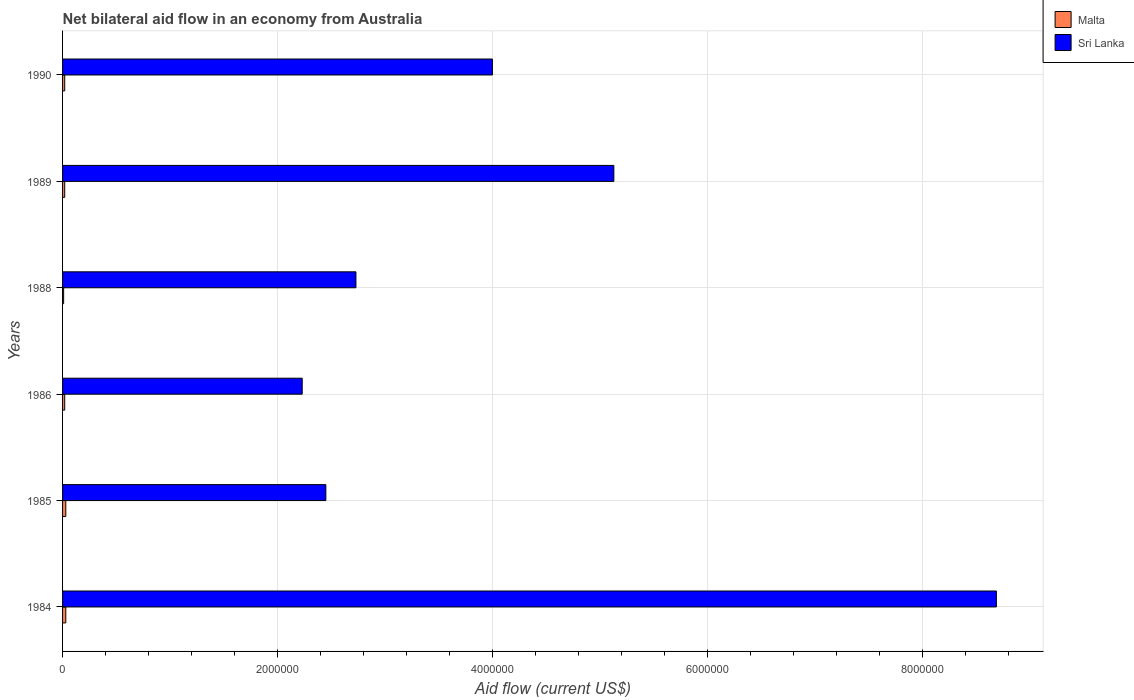How many bars are there on the 2nd tick from the top?
Provide a short and direct response. 2. How many bars are there on the 2nd tick from the bottom?
Provide a succinct answer. 2. What is the label of the 5th group of bars from the top?
Give a very brief answer. 1985. What is the net bilateral aid flow in Malta in 1985?
Your response must be concise. 3.00e+04. Across all years, what is the minimum net bilateral aid flow in Sri Lanka?
Your answer should be compact. 2.23e+06. In which year was the net bilateral aid flow in Sri Lanka minimum?
Your answer should be compact. 1986. What is the total net bilateral aid flow in Sri Lanka in the graph?
Give a very brief answer. 2.52e+07. What is the difference between the net bilateral aid flow in Sri Lanka in 1984 and that in 1989?
Provide a succinct answer. 3.56e+06. What is the difference between the net bilateral aid flow in Malta in 1989 and the net bilateral aid flow in Sri Lanka in 1984?
Keep it short and to the point. -8.67e+06. What is the average net bilateral aid flow in Malta per year?
Your response must be concise. 2.17e+04. In the year 1984, what is the difference between the net bilateral aid flow in Sri Lanka and net bilateral aid flow in Malta?
Your answer should be compact. 8.66e+06. In how many years, is the net bilateral aid flow in Malta greater than 5600000 US$?
Offer a terse response. 0. Is the net bilateral aid flow in Malta in 1984 less than that in 1990?
Ensure brevity in your answer.  No. What is the difference between the highest and the lowest net bilateral aid flow in Malta?
Ensure brevity in your answer.  2.00e+04. What does the 1st bar from the top in 1989 represents?
Ensure brevity in your answer.  Sri Lanka. What does the 2nd bar from the bottom in 1985 represents?
Make the answer very short. Sri Lanka. How many bars are there?
Your answer should be compact. 12. How many years are there in the graph?
Make the answer very short. 6. Are the values on the major ticks of X-axis written in scientific E-notation?
Ensure brevity in your answer.  No. Does the graph contain any zero values?
Give a very brief answer. No. Does the graph contain grids?
Keep it short and to the point. Yes. Where does the legend appear in the graph?
Your answer should be very brief. Top right. How are the legend labels stacked?
Provide a short and direct response. Vertical. What is the title of the graph?
Your answer should be very brief. Net bilateral aid flow in an economy from Australia. What is the label or title of the X-axis?
Your answer should be very brief. Aid flow (current US$). What is the Aid flow (current US$) in Sri Lanka in 1984?
Offer a terse response. 8.69e+06. What is the Aid flow (current US$) of Malta in 1985?
Offer a terse response. 3.00e+04. What is the Aid flow (current US$) in Sri Lanka in 1985?
Your response must be concise. 2.45e+06. What is the Aid flow (current US$) in Sri Lanka in 1986?
Keep it short and to the point. 2.23e+06. What is the Aid flow (current US$) of Malta in 1988?
Provide a short and direct response. 10000. What is the Aid flow (current US$) in Sri Lanka in 1988?
Offer a very short reply. 2.73e+06. What is the Aid flow (current US$) in Sri Lanka in 1989?
Provide a succinct answer. 5.13e+06. What is the Aid flow (current US$) in Malta in 1990?
Provide a succinct answer. 2.00e+04. What is the Aid flow (current US$) in Sri Lanka in 1990?
Your answer should be compact. 4.00e+06. Across all years, what is the maximum Aid flow (current US$) in Sri Lanka?
Offer a very short reply. 8.69e+06. Across all years, what is the minimum Aid flow (current US$) of Malta?
Provide a succinct answer. 10000. Across all years, what is the minimum Aid flow (current US$) in Sri Lanka?
Provide a short and direct response. 2.23e+06. What is the total Aid flow (current US$) of Malta in the graph?
Provide a short and direct response. 1.30e+05. What is the total Aid flow (current US$) in Sri Lanka in the graph?
Your answer should be compact. 2.52e+07. What is the difference between the Aid flow (current US$) of Sri Lanka in 1984 and that in 1985?
Make the answer very short. 6.24e+06. What is the difference between the Aid flow (current US$) in Sri Lanka in 1984 and that in 1986?
Ensure brevity in your answer.  6.46e+06. What is the difference between the Aid flow (current US$) of Sri Lanka in 1984 and that in 1988?
Provide a short and direct response. 5.96e+06. What is the difference between the Aid flow (current US$) of Malta in 1984 and that in 1989?
Your answer should be compact. 10000. What is the difference between the Aid flow (current US$) in Sri Lanka in 1984 and that in 1989?
Your answer should be very brief. 3.56e+06. What is the difference between the Aid flow (current US$) of Sri Lanka in 1984 and that in 1990?
Give a very brief answer. 4.69e+06. What is the difference between the Aid flow (current US$) in Sri Lanka in 1985 and that in 1986?
Offer a terse response. 2.20e+05. What is the difference between the Aid flow (current US$) in Malta in 1985 and that in 1988?
Offer a terse response. 2.00e+04. What is the difference between the Aid flow (current US$) in Sri Lanka in 1985 and that in 1988?
Your response must be concise. -2.80e+05. What is the difference between the Aid flow (current US$) in Malta in 1985 and that in 1989?
Give a very brief answer. 10000. What is the difference between the Aid flow (current US$) of Sri Lanka in 1985 and that in 1989?
Offer a very short reply. -2.68e+06. What is the difference between the Aid flow (current US$) of Malta in 1985 and that in 1990?
Ensure brevity in your answer.  10000. What is the difference between the Aid flow (current US$) of Sri Lanka in 1985 and that in 1990?
Make the answer very short. -1.55e+06. What is the difference between the Aid flow (current US$) of Sri Lanka in 1986 and that in 1988?
Your response must be concise. -5.00e+05. What is the difference between the Aid flow (current US$) in Malta in 1986 and that in 1989?
Provide a succinct answer. 0. What is the difference between the Aid flow (current US$) in Sri Lanka in 1986 and that in 1989?
Make the answer very short. -2.90e+06. What is the difference between the Aid flow (current US$) in Sri Lanka in 1986 and that in 1990?
Provide a succinct answer. -1.77e+06. What is the difference between the Aid flow (current US$) in Malta in 1988 and that in 1989?
Keep it short and to the point. -10000. What is the difference between the Aid flow (current US$) in Sri Lanka in 1988 and that in 1989?
Make the answer very short. -2.40e+06. What is the difference between the Aid flow (current US$) of Malta in 1988 and that in 1990?
Offer a very short reply. -10000. What is the difference between the Aid flow (current US$) in Sri Lanka in 1988 and that in 1990?
Ensure brevity in your answer.  -1.27e+06. What is the difference between the Aid flow (current US$) in Sri Lanka in 1989 and that in 1990?
Your answer should be very brief. 1.13e+06. What is the difference between the Aid flow (current US$) in Malta in 1984 and the Aid flow (current US$) in Sri Lanka in 1985?
Your response must be concise. -2.42e+06. What is the difference between the Aid flow (current US$) of Malta in 1984 and the Aid flow (current US$) of Sri Lanka in 1986?
Provide a succinct answer. -2.20e+06. What is the difference between the Aid flow (current US$) in Malta in 1984 and the Aid flow (current US$) in Sri Lanka in 1988?
Offer a very short reply. -2.70e+06. What is the difference between the Aid flow (current US$) of Malta in 1984 and the Aid flow (current US$) of Sri Lanka in 1989?
Keep it short and to the point. -5.10e+06. What is the difference between the Aid flow (current US$) in Malta in 1984 and the Aid flow (current US$) in Sri Lanka in 1990?
Your response must be concise. -3.97e+06. What is the difference between the Aid flow (current US$) of Malta in 1985 and the Aid flow (current US$) of Sri Lanka in 1986?
Offer a very short reply. -2.20e+06. What is the difference between the Aid flow (current US$) of Malta in 1985 and the Aid flow (current US$) of Sri Lanka in 1988?
Make the answer very short. -2.70e+06. What is the difference between the Aid flow (current US$) in Malta in 1985 and the Aid flow (current US$) in Sri Lanka in 1989?
Provide a short and direct response. -5.10e+06. What is the difference between the Aid flow (current US$) of Malta in 1985 and the Aid flow (current US$) of Sri Lanka in 1990?
Ensure brevity in your answer.  -3.97e+06. What is the difference between the Aid flow (current US$) of Malta in 1986 and the Aid flow (current US$) of Sri Lanka in 1988?
Your answer should be compact. -2.71e+06. What is the difference between the Aid flow (current US$) in Malta in 1986 and the Aid flow (current US$) in Sri Lanka in 1989?
Your answer should be very brief. -5.11e+06. What is the difference between the Aid flow (current US$) in Malta in 1986 and the Aid flow (current US$) in Sri Lanka in 1990?
Keep it short and to the point. -3.98e+06. What is the difference between the Aid flow (current US$) of Malta in 1988 and the Aid flow (current US$) of Sri Lanka in 1989?
Keep it short and to the point. -5.12e+06. What is the difference between the Aid flow (current US$) in Malta in 1988 and the Aid flow (current US$) in Sri Lanka in 1990?
Offer a terse response. -3.99e+06. What is the difference between the Aid flow (current US$) of Malta in 1989 and the Aid flow (current US$) of Sri Lanka in 1990?
Provide a succinct answer. -3.98e+06. What is the average Aid flow (current US$) of Malta per year?
Give a very brief answer. 2.17e+04. What is the average Aid flow (current US$) in Sri Lanka per year?
Your answer should be very brief. 4.20e+06. In the year 1984, what is the difference between the Aid flow (current US$) in Malta and Aid flow (current US$) in Sri Lanka?
Provide a short and direct response. -8.66e+06. In the year 1985, what is the difference between the Aid flow (current US$) of Malta and Aid flow (current US$) of Sri Lanka?
Provide a succinct answer. -2.42e+06. In the year 1986, what is the difference between the Aid flow (current US$) in Malta and Aid flow (current US$) in Sri Lanka?
Keep it short and to the point. -2.21e+06. In the year 1988, what is the difference between the Aid flow (current US$) in Malta and Aid flow (current US$) in Sri Lanka?
Your response must be concise. -2.72e+06. In the year 1989, what is the difference between the Aid flow (current US$) in Malta and Aid flow (current US$) in Sri Lanka?
Your response must be concise. -5.11e+06. In the year 1990, what is the difference between the Aid flow (current US$) in Malta and Aid flow (current US$) in Sri Lanka?
Offer a terse response. -3.98e+06. What is the ratio of the Aid flow (current US$) of Sri Lanka in 1984 to that in 1985?
Your response must be concise. 3.55. What is the ratio of the Aid flow (current US$) in Malta in 1984 to that in 1986?
Your response must be concise. 1.5. What is the ratio of the Aid flow (current US$) in Sri Lanka in 1984 to that in 1986?
Provide a short and direct response. 3.9. What is the ratio of the Aid flow (current US$) of Malta in 1984 to that in 1988?
Keep it short and to the point. 3. What is the ratio of the Aid flow (current US$) in Sri Lanka in 1984 to that in 1988?
Offer a very short reply. 3.18. What is the ratio of the Aid flow (current US$) of Malta in 1984 to that in 1989?
Your response must be concise. 1.5. What is the ratio of the Aid flow (current US$) in Sri Lanka in 1984 to that in 1989?
Your answer should be very brief. 1.69. What is the ratio of the Aid flow (current US$) of Malta in 1984 to that in 1990?
Keep it short and to the point. 1.5. What is the ratio of the Aid flow (current US$) of Sri Lanka in 1984 to that in 1990?
Your response must be concise. 2.17. What is the ratio of the Aid flow (current US$) of Sri Lanka in 1985 to that in 1986?
Offer a terse response. 1.1. What is the ratio of the Aid flow (current US$) of Malta in 1985 to that in 1988?
Provide a succinct answer. 3. What is the ratio of the Aid flow (current US$) of Sri Lanka in 1985 to that in 1988?
Provide a short and direct response. 0.9. What is the ratio of the Aid flow (current US$) in Malta in 1985 to that in 1989?
Your response must be concise. 1.5. What is the ratio of the Aid flow (current US$) of Sri Lanka in 1985 to that in 1989?
Offer a terse response. 0.48. What is the ratio of the Aid flow (current US$) in Malta in 1985 to that in 1990?
Offer a terse response. 1.5. What is the ratio of the Aid flow (current US$) in Sri Lanka in 1985 to that in 1990?
Provide a succinct answer. 0.61. What is the ratio of the Aid flow (current US$) of Malta in 1986 to that in 1988?
Give a very brief answer. 2. What is the ratio of the Aid flow (current US$) in Sri Lanka in 1986 to that in 1988?
Your response must be concise. 0.82. What is the ratio of the Aid flow (current US$) of Sri Lanka in 1986 to that in 1989?
Your response must be concise. 0.43. What is the ratio of the Aid flow (current US$) of Malta in 1986 to that in 1990?
Make the answer very short. 1. What is the ratio of the Aid flow (current US$) of Sri Lanka in 1986 to that in 1990?
Keep it short and to the point. 0.56. What is the ratio of the Aid flow (current US$) of Malta in 1988 to that in 1989?
Keep it short and to the point. 0.5. What is the ratio of the Aid flow (current US$) of Sri Lanka in 1988 to that in 1989?
Keep it short and to the point. 0.53. What is the ratio of the Aid flow (current US$) of Malta in 1988 to that in 1990?
Ensure brevity in your answer.  0.5. What is the ratio of the Aid flow (current US$) of Sri Lanka in 1988 to that in 1990?
Provide a succinct answer. 0.68. What is the ratio of the Aid flow (current US$) of Malta in 1989 to that in 1990?
Ensure brevity in your answer.  1. What is the ratio of the Aid flow (current US$) of Sri Lanka in 1989 to that in 1990?
Make the answer very short. 1.28. What is the difference between the highest and the second highest Aid flow (current US$) in Sri Lanka?
Your answer should be very brief. 3.56e+06. What is the difference between the highest and the lowest Aid flow (current US$) in Sri Lanka?
Make the answer very short. 6.46e+06. 